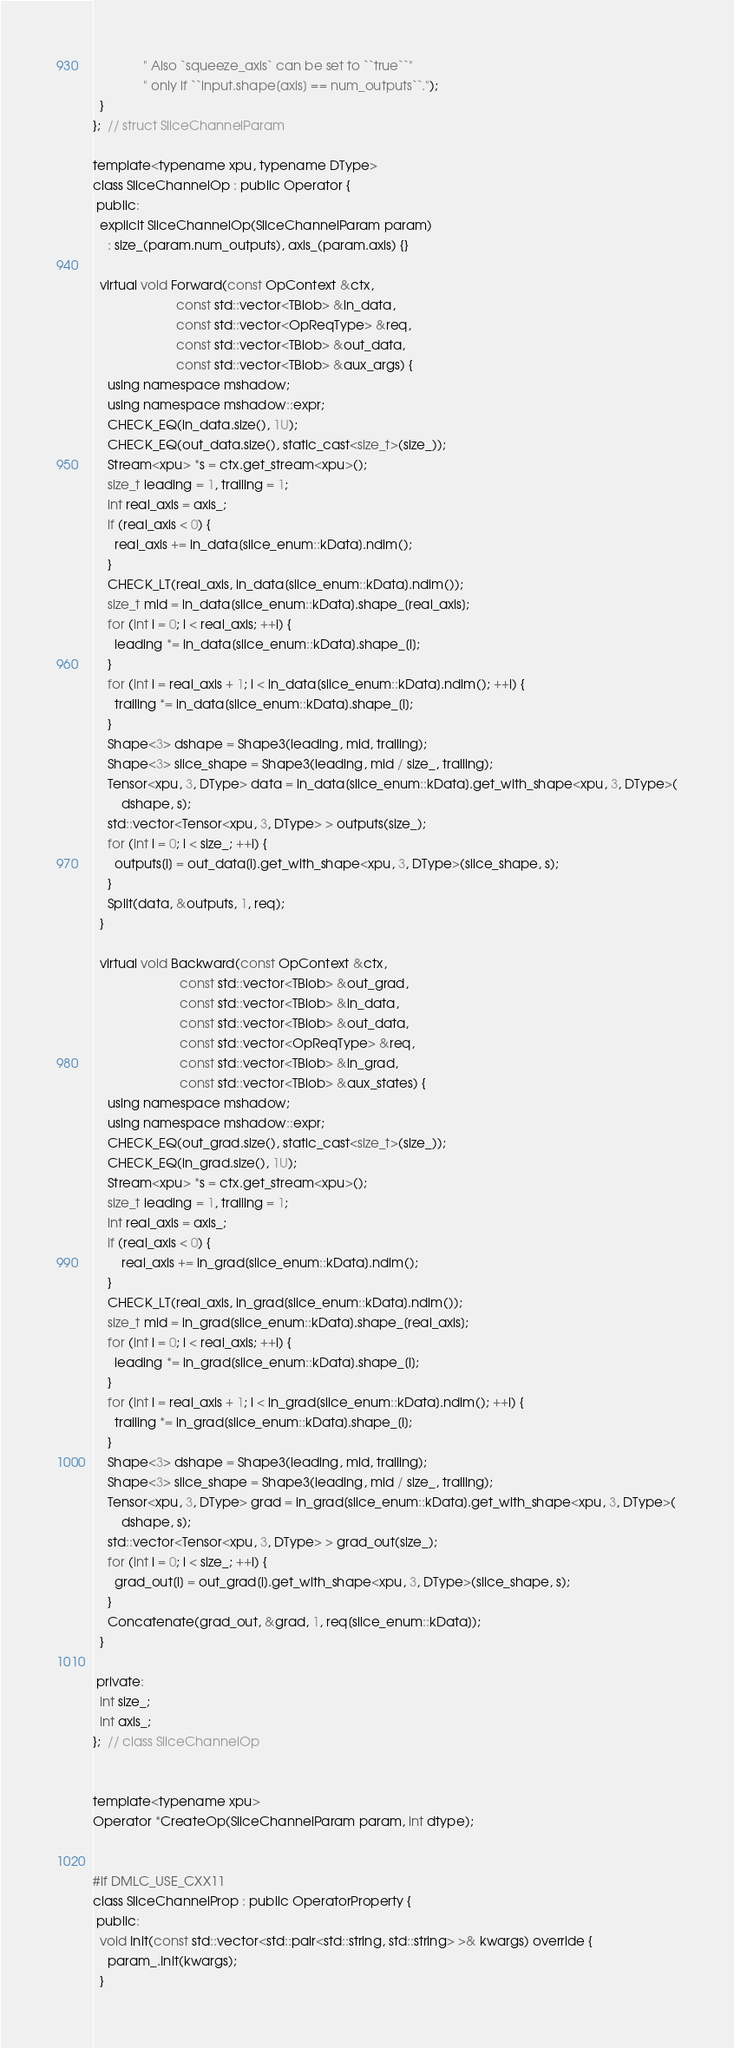Convert code to text. <code><loc_0><loc_0><loc_500><loc_500><_C_>              " Also `squeeze_axis` can be set to ``true``"
              " only if ``input.shape[axis] == num_outputs``.");
  }
};  // struct SliceChannelParam

template<typename xpu, typename DType>
class SliceChannelOp : public Operator {
 public:
  explicit SliceChannelOp(SliceChannelParam param)
    : size_(param.num_outputs), axis_(param.axis) {}

  virtual void Forward(const OpContext &ctx,
                       const std::vector<TBlob> &in_data,
                       const std::vector<OpReqType> &req,
                       const std::vector<TBlob> &out_data,
                       const std::vector<TBlob> &aux_args) {
    using namespace mshadow;
    using namespace mshadow::expr;
    CHECK_EQ(in_data.size(), 1U);
    CHECK_EQ(out_data.size(), static_cast<size_t>(size_));
    Stream<xpu> *s = ctx.get_stream<xpu>();
    size_t leading = 1, trailing = 1;
    int real_axis = axis_;
    if (real_axis < 0) {
      real_axis += in_data[slice_enum::kData].ndim();
    }
    CHECK_LT(real_axis, in_data[slice_enum::kData].ndim());
    size_t mid = in_data[slice_enum::kData].shape_[real_axis];
    for (int i = 0; i < real_axis; ++i) {
      leading *= in_data[slice_enum::kData].shape_[i];
    }
    for (int i = real_axis + 1; i < in_data[slice_enum::kData].ndim(); ++i) {
      trailing *= in_data[slice_enum::kData].shape_[i];
    }
    Shape<3> dshape = Shape3(leading, mid, trailing);
    Shape<3> slice_shape = Shape3(leading, mid / size_, trailing);
    Tensor<xpu, 3, DType> data = in_data[slice_enum::kData].get_with_shape<xpu, 3, DType>(
        dshape, s);
    std::vector<Tensor<xpu, 3, DType> > outputs(size_);
    for (int i = 0; i < size_; ++i) {
      outputs[i] = out_data[i].get_with_shape<xpu, 3, DType>(slice_shape, s);
    }
    Split(data, &outputs, 1, req);
  }

  virtual void Backward(const OpContext &ctx,
                        const std::vector<TBlob> &out_grad,
                        const std::vector<TBlob> &in_data,
                        const std::vector<TBlob> &out_data,
                        const std::vector<OpReqType> &req,
                        const std::vector<TBlob> &in_grad,
                        const std::vector<TBlob> &aux_states) {
    using namespace mshadow;
    using namespace mshadow::expr;
    CHECK_EQ(out_grad.size(), static_cast<size_t>(size_));
    CHECK_EQ(in_grad.size(), 1U);
    Stream<xpu> *s = ctx.get_stream<xpu>();
    size_t leading = 1, trailing = 1;
    int real_axis = axis_;
    if (real_axis < 0) {
        real_axis += in_grad[slice_enum::kData].ndim();
    }
    CHECK_LT(real_axis, in_grad[slice_enum::kData].ndim());
    size_t mid = in_grad[slice_enum::kData].shape_[real_axis];
    for (int i = 0; i < real_axis; ++i) {
      leading *= in_grad[slice_enum::kData].shape_[i];
    }
    for (int i = real_axis + 1; i < in_grad[slice_enum::kData].ndim(); ++i) {
      trailing *= in_grad[slice_enum::kData].shape_[i];
    }
    Shape<3> dshape = Shape3(leading, mid, trailing);
    Shape<3> slice_shape = Shape3(leading, mid / size_, trailing);
    Tensor<xpu, 3, DType> grad = in_grad[slice_enum::kData].get_with_shape<xpu, 3, DType>(
        dshape, s);
    std::vector<Tensor<xpu, 3, DType> > grad_out(size_);
    for (int i = 0; i < size_; ++i) {
      grad_out[i] = out_grad[i].get_with_shape<xpu, 3, DType>(slice_shape, s);
    }
    Concatenate(grad_out, &grad, 1, req[slice_enum::kData]);
  }

 private:
  int size_;
  int axis_;
};  // class SliceChannelOp


template<typename xpu>
Operator *CreateOp(SliceChannelParam param, int dtype);


#if DMLC_USE_CXX11
class SliceChannelProp : public OperatorProperty {
 public:
  void Init(const std::vector<std::pair<std::string, std::string> >& kwargs) override {
    param_.Init(kwargs);
  }
</code> 